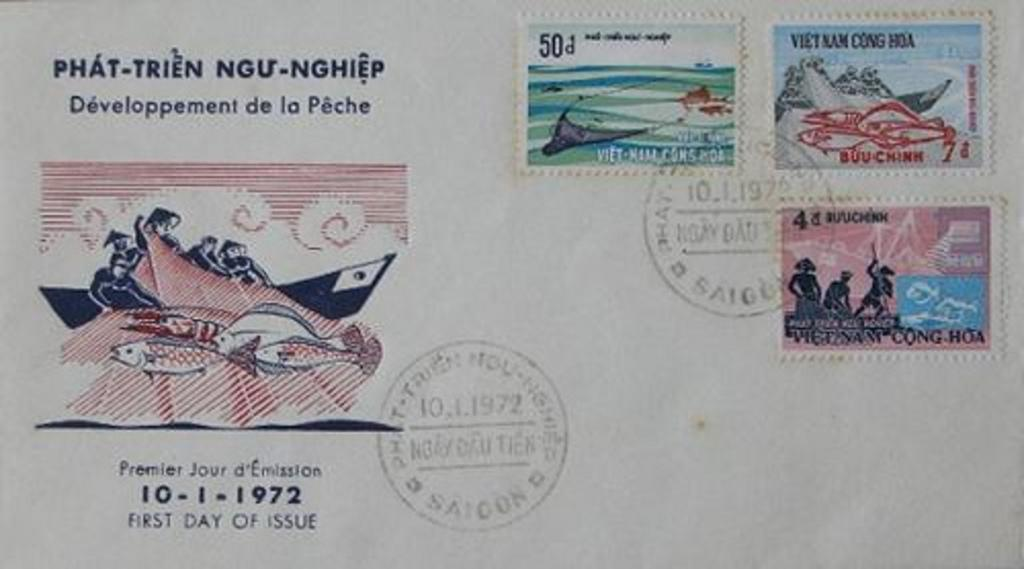<image>
Write a terse but informative summary of the picture. A postcard with stamps one labeled Vietnam Cong HDA  was sent in 1972 